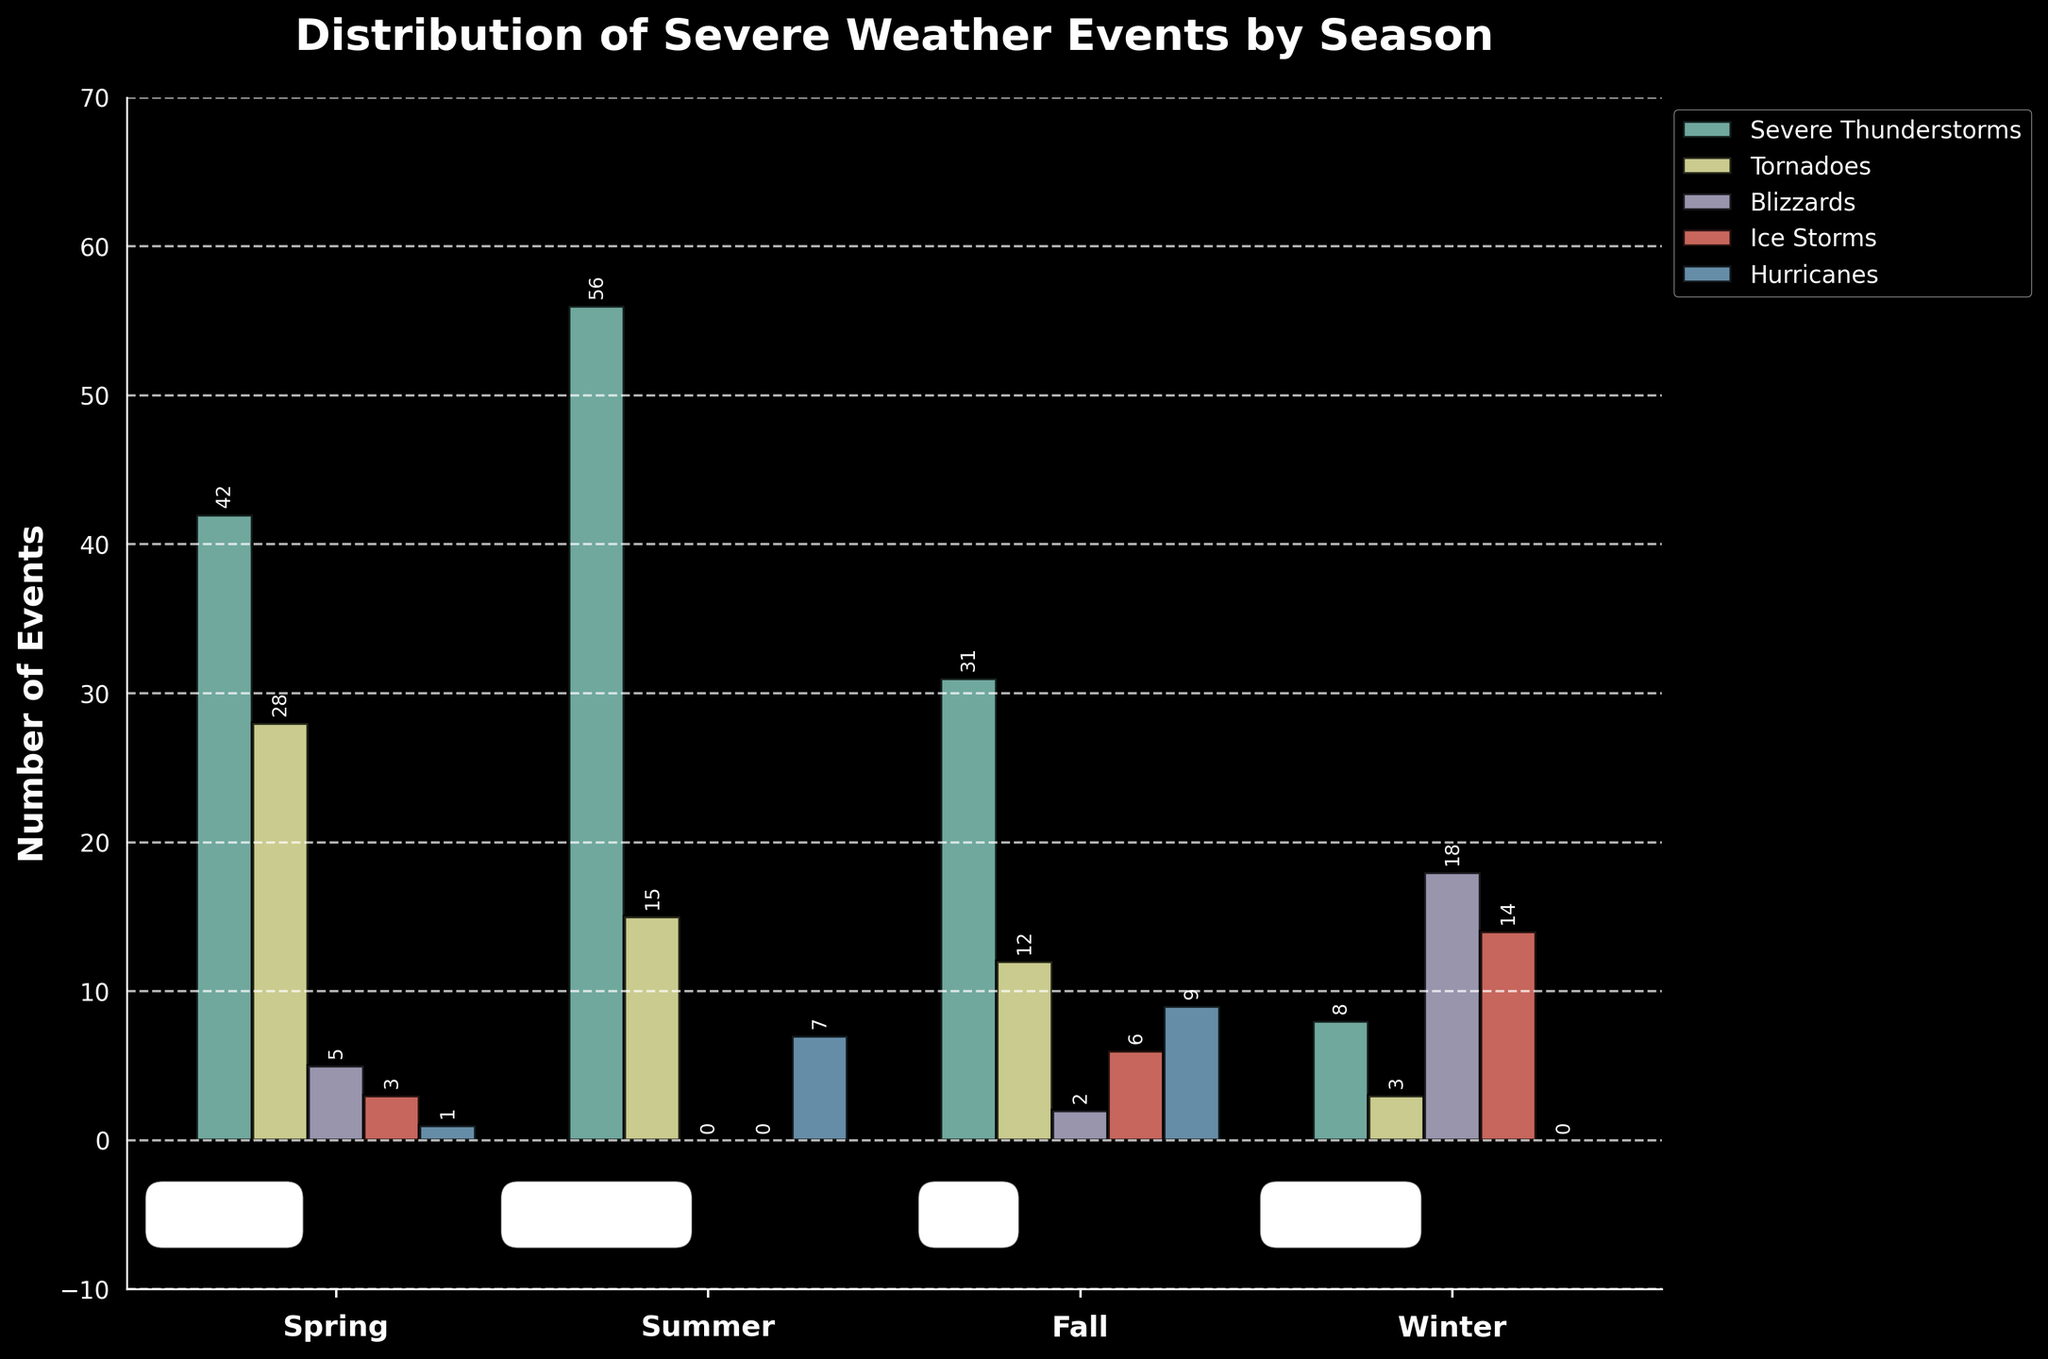What season has the highest number of severe thunderstorms? Looking at the heights of the bars related to severe thunderstorms, the summer bar has the greatest height.
Answer: Summer Which season had the fewest tornadoes? Referring to the bars for tornadoes, winter has the shortest bar.
Answer: Winter How does the number of blizzards in fall compare to winter? By comparing the heights of the blizzards bars, fall has a shorter bar than winter.
Answer: Less What is the total number of ice storms recorded across all seasons? Sum the heights of all bars representing ice storms: 3 (spring) + 0 (summer) + 6 (fall) + 14 (winter) = 23
Answer: 23 Across all seasons, which weather event occurs the most often? The highest number of events is reflected in the severe thunderstorms bar in summer.
Answer: Severe Thunderstorms In which season are hurricanes the most frequent? The bars representing hurricanes show the highest frequency during fall.
Answer: Fall What's the total number of severe thunderstorms in fall and winter combined? Adding the heights of severe thunderstorms bars for fall and winter: 31 (fall) + 8 (winter) = 39
Answer: 39 Are there any seasons where blizzards do not occur? By observing the blizzards bars, there are no blizzards in spring and summer (heights are zero).
Answer: Spring and Summer How many more hurricanes occur in fall than in spring? Subtract the heights of the hurricanes bars for fall and spring: 9 (fall) - 1 (spring) = 8
Answer: 8 Which season has almost equal numbers of severe thunderstorms and tornadoes? Comparing the heights of bars, spring has 42 severe thunderstorms and 28 tornadoes.
Answer: Spring 